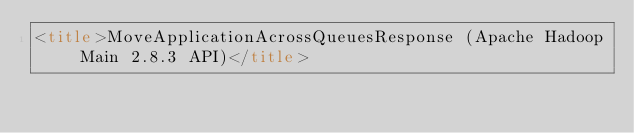<code> <loc_0><loc_0><loc_500><loc_500><_HTML_><title>MoveApplicationAcrossQueuesResponse (Apache Hadoop Main 2.8.3 API)</title></code> 